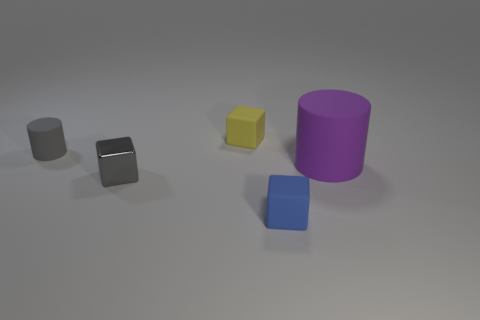Are there any objects that could fit inside each other? Based on the image, none of the objects appear as though they could fit inside each other. They are distinct solids without any visible concavities or openings that would allow them to interlock or encase one another. 